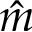Convert formula to latex. <formula><loc_0><loc_0><loc_500><loc_500>\hat { m }</formula> 